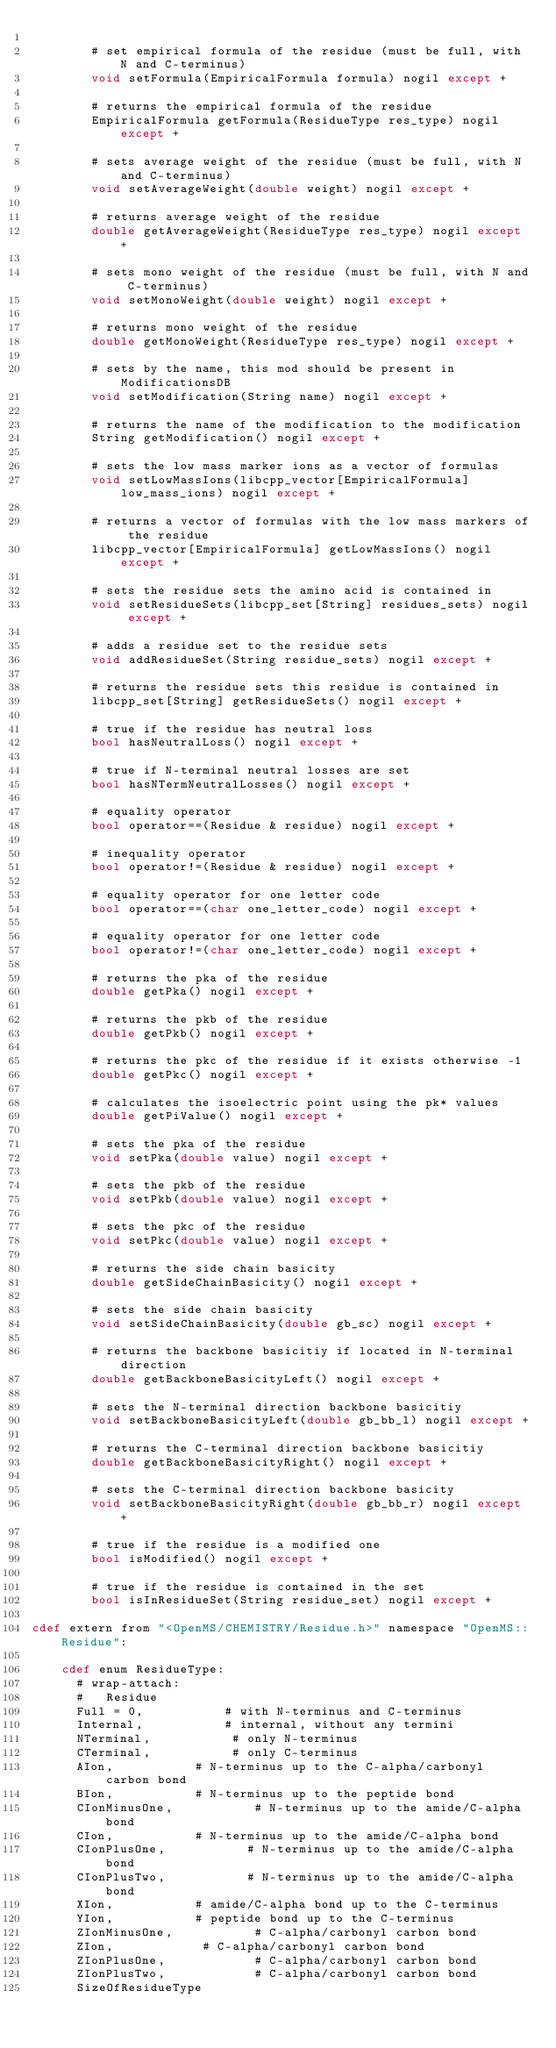<code> <loc_0><loc_0><loc_500><loc_500><_Cython_>
        # set empirical formula of the residue (must be full, with N and C-terminus)
        void setFormula(EmpiricalFormula formula) nogil except +

        # returns the empirical formula of the residue
        EmpiricalFormula getFormula(ResidueType res_type) nogil except +

        # sets average weight of the residue (must be full, with N and C-terminus)
        void setAverageWeight(double weight) nogil except +

        # returns average weight of the residue
        double getAverageWeight(ResidueType res_type) nogil except +

        # sets mono weight of the residue (must be full, with N and C-terminus)
        void setMonoWeight(double weight) nogil except +

        # returns mono weight of the residue
        double getMonoWeight(ResidueType res_type) nogil except +

        # sets by the name, this mod should be present in ModificationsDB
        void setModification(String name) nogil except +

        # returns the name of the modification to the modification
        String getModification() nogil except +

        # sets the low mass marker ions as a vector of formulas
        void setLowMassIons(libcpp_vector[EmpiricalFormula] low_mass_ions) nogil except +

        # returns a vector of formulas with the low mass markers of the residue
        libcpp_vector[EmpiricalFormula] getLowMassIons() nogil except +

        # sets the residue sets the amino acid is contained in
        void setResidueSets(libcpp_set[String] residues_sets) nogil except +

        # adds a residue set to the residue sets
        void addResidueSet(String residue_sets) nogil except +

        # returns the residue sets this residue is contained in
        libcpp_set[String] getResidueSets() nogil except +

        # true if the residue has neutral loss
        bool hasNeutralLoss() nogil except +

        # true if N-terminal neutral losses are set
        bool hasNTermNeutralLosses() nogil except +

        # equality operator
        bool operator==(Residue & residue) nogil except +

        # inequality operator
        bool operator!=(Residue & residue) nogil except +

        # equality operator for one letter code
        bool operator==(char one_letter_code) nogil except +

        # equality operator for one letter code
        bool operator!=(char one_letter_code) nogil except +

        # returns the pka of the residue
        double getPka() nogil except +

        # returns the pkb of the residue
        double getPkb() nogil except +

        # returns the pkc of the residue if it exists otherwise -1
        double getPkc() nogil except +

        # calculates the isoelectric point using the pk* values
        double getPiValue() nogil except +

        # sets the pka of the residue
        void setPka(double value) nogil except +

        # sets the pkb of the residue
        void setPkb(double value) nogil except +

        # sets the pkc of the residue
        void setPkc(double value) nogil except +

        # returns the side chain basicity
        double getSideChainBasicity() nogil except +

        # sets the side chain basicity
        void setSideChainBasicity(double gb_sc) nogil except +

        # returns the backbone basicitiy if located in N-terminal direction
        double getBackboneBasicityLeft() nogil except +

        # sets the N-terminal direction backbone basicitiy
        void setBackboneBasicityLeft(double gb_bb_l) nogil except +

        # returns the C-terminal direction backbone basicitiy
        double getBackboneBasicityRight() nogil except +

        # sets the C-terminal direction backbone basicity
        void setBackboneBasicityRight(double gb_bb_r) nogil except +

        # true if the residue is a modified one
        bool isModified() nogil except +

        # true if the residue is contained in the set
        bool isInResidueSet(String residue_set) nogil except +

cdef extern from "<OpenMS/CHEMISTRY/Residue.h>" namespace "OpenMS::Residue":

    cdef enum ResidueType:
      # wrap-attach:
      #   Residue
      Full = 0,           # with N-terminus and C-terminus
      Internal,           # internal, without any termini
      NTerminal,           # only N-terminus
      CTerminal,           # only C-terminus
      AIon,           # N-terminus up to the C-alpha/carbonyl carbon bond
      BIon,           # N-terminus up to the peptide bond
      CIonMinusOne,           # N-terminus up to the amide/C-alpha bond
      CIon,           # N-terminus up to the amide/C-alpha bond
      CIonPlusOne,           # N-terminus up to the amide/C-alpha bond
      CIonPlusTwo,           # N-terminus up to the amide/C-alpha bond
      XIon,           # amide/C-alpha bond up to the C-terminus
      YIon,           # peptide bond up to the C-terminus
      ZIonMinusOne,           # C-alpha/carbonyl carbon bond
      ZIon,            # C-alpha/carbonyl carbon bond
      ZIonPlusOne,            # C-alpha/carbonyl carbon bond
      ZIonPlusTwo,            # C-alpha/carbonyl carbon bond
      SizeOfResidueType

</code> 